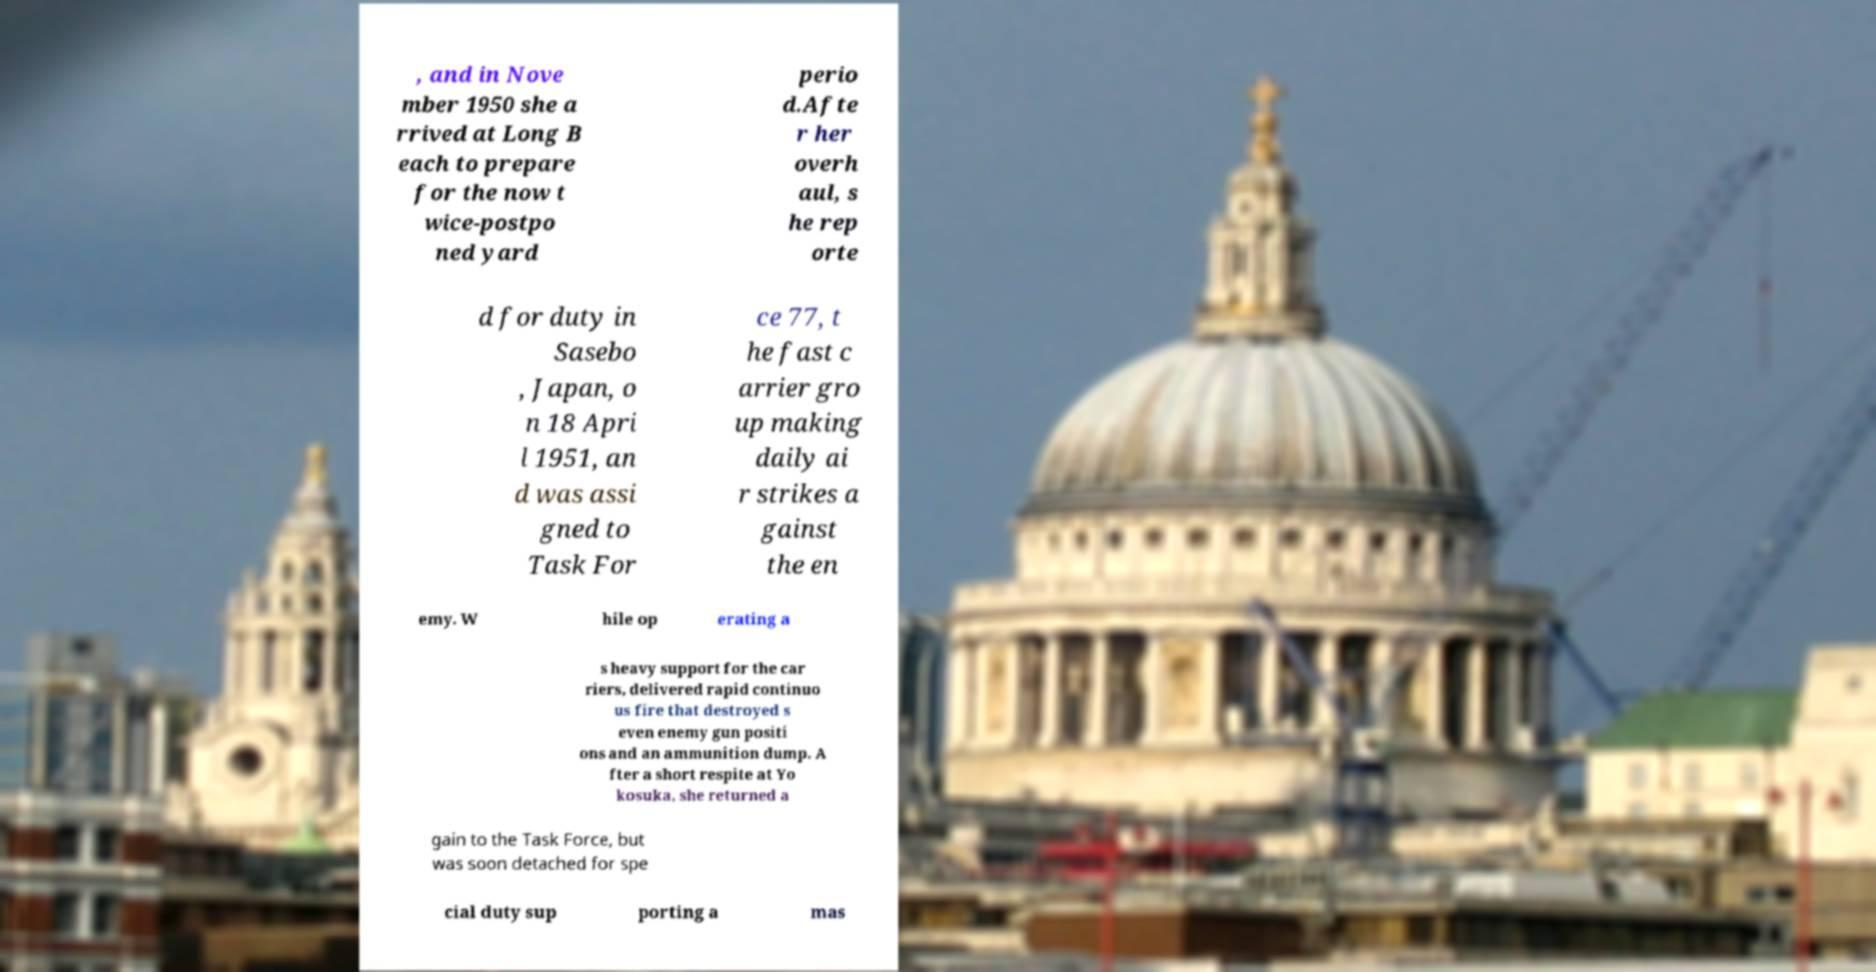Could you assist in decoding the text presented in this image and type it out clearly? , and in Nove mber 1950 she a rrived at Long B each to prepare for the now t wice-postpo ned yard perio d.Afte r her overh aul, s he rep orte d for duty in Sasebo , Japan, o n 18 Apri l 1951, an d was assi gned to Task For ce 77, t he fast c arrier gro up making daily ai r strikes a gainst the en emy. W hile op erating a s heavy support for the car riers, delivered rapid continuo us fire that destroyed s even enemy gun positi ons and an ammunition dump. A fter a short respite at Yo kosuka, she returned a gain to the Task Force, but was soon detached for spe cial duty sup porting a mas 